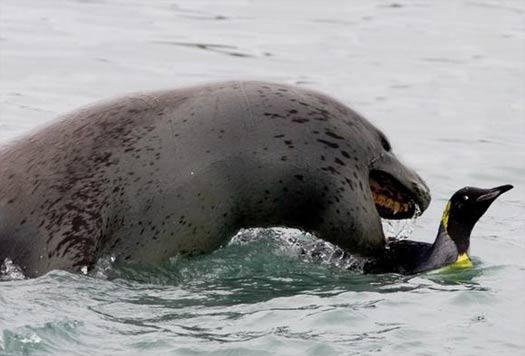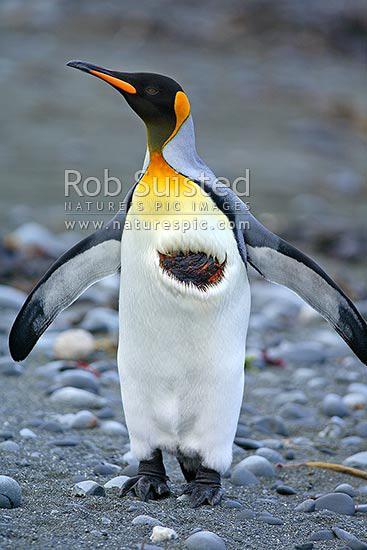The first image is the image on the left, the second image is the image on the right. Analyze the images presented: Is the assertion "A sea lion is shown in one of the images." valid? Answer yes or no. Yes. 